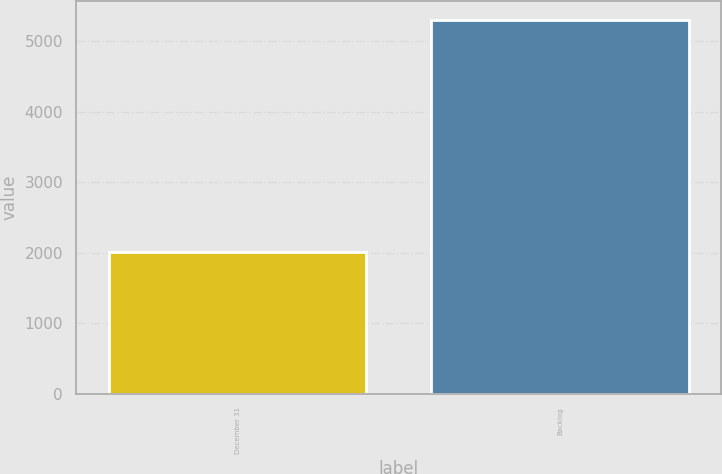<chart> <loc_0><loc_0><loc_500><loc_500><bar_chart><fcel>December 31<fcel>Backlog<nl><fcel>2016<fcel>5303<nl></chart> 